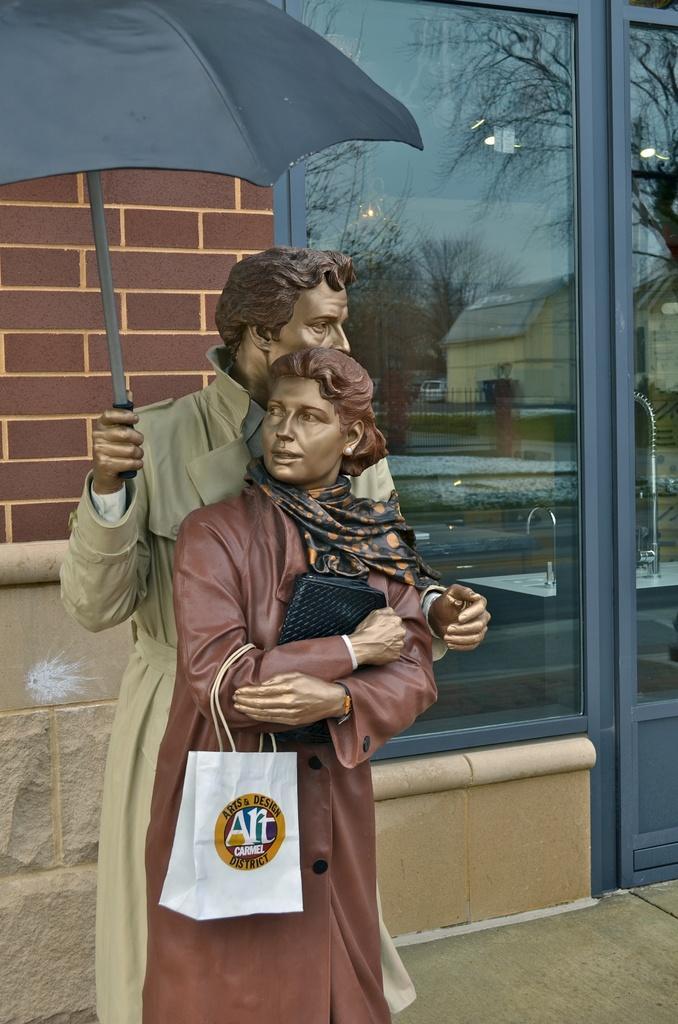Can you describe this image briefly? In this image we can see statues and the reflections of buildings, motor vehicles on the ground, trees and sky in the window. 